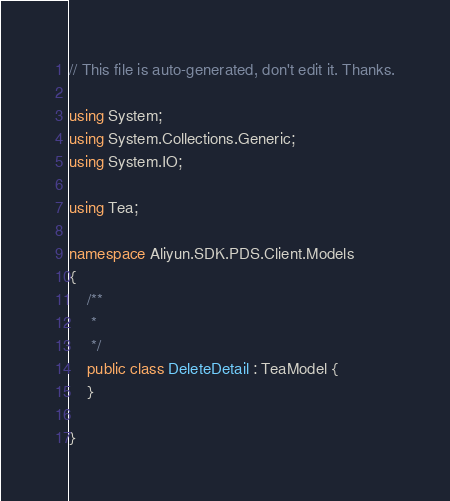<code> <loc_0><loc_0><loc_500><loc_500><_C#_>// This file is auto-generated, don't edit it. Thanks.

using System;
using System.Collections.Generic;
using System.IO;

using Tea;

namespace Aliyun.SDK.PDS.Client.Models
{
    /**
     * 
     */
    public class DeleteDetail : TeaModel {
    }

}
</code> 